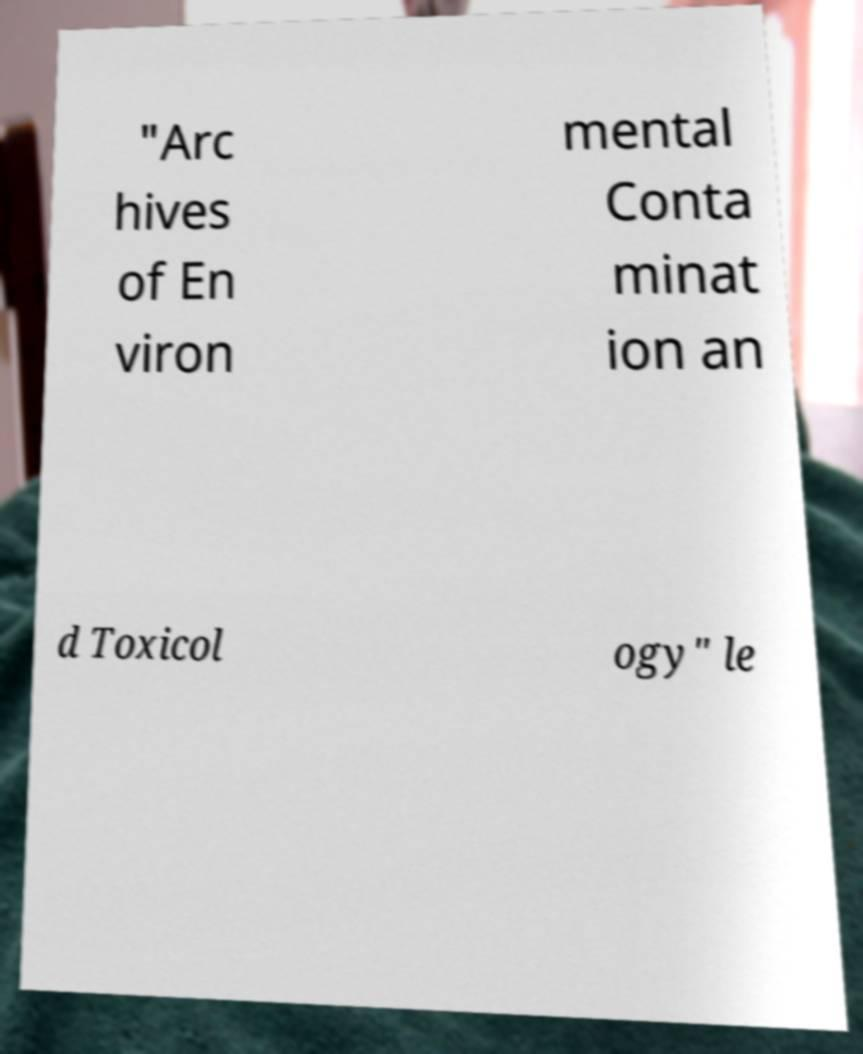Please identify and transcribe the text found in this image. "Arc hives of En viron mental Conta minat ion an d Toxicol ogy" le 